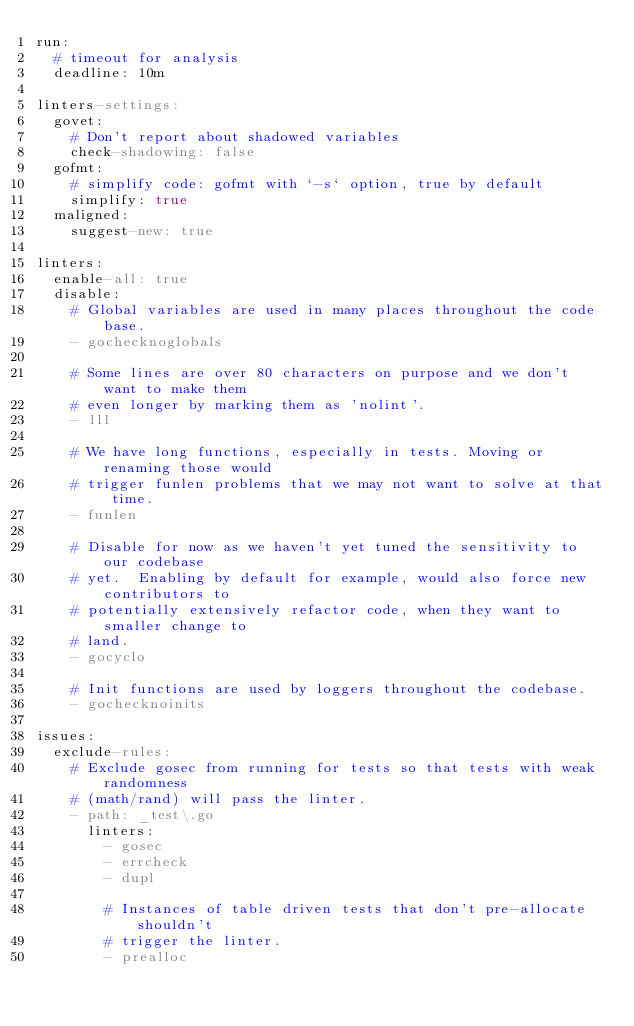<code> <loc_0><loc_0><loc_500><loc_500><_YAML_>run:
  # timeout for analysis
  deadline: 10m

linters-settings:
  govet:
    # Don't report about shadowed variables
    check-shadowing: false
  gofmt:
    # simplify code: gofmt with `-s` option, true by default
    simplify: true
  maligned:
    suggest-new: true

linters:
  enable-all: true
  disable:
    # Global variables are used in many places throughout the code base.
    - gochecknoglobals

    # Some lines are over 80 characters on purpose and we don't want to make them
    # even longer by marking them as 'nolint'.
    - lll

    # We have long functions, especially in tests. Moving or renaming those would
    # trigger funlen problems that we may not want to solve at that time.
    - funlen

    # Disable for now as we haven't yet tuned the sensitivity to our codebase
    # yet.  Enabling by default for example, would also force new contributors to
    # potentially extensively refactor code, when they want to smaller change to
    # land.
    - gocyclo

    # Init functions are used by loggers throughout the codebase.
    - gochecknoinits

issues:
  exclude-rules:
    # Exclude gosec from running for tests so that tests with weak randomness
    # (math/rand) will pass the linter.
    - path: _test\.go
      linters:
        - gosec
        - errcheck
        - dupl

        # Instances of table driven tests that don't pre-allocate shouldn't
        # trigger the linter.
        - prealloc
</code> 